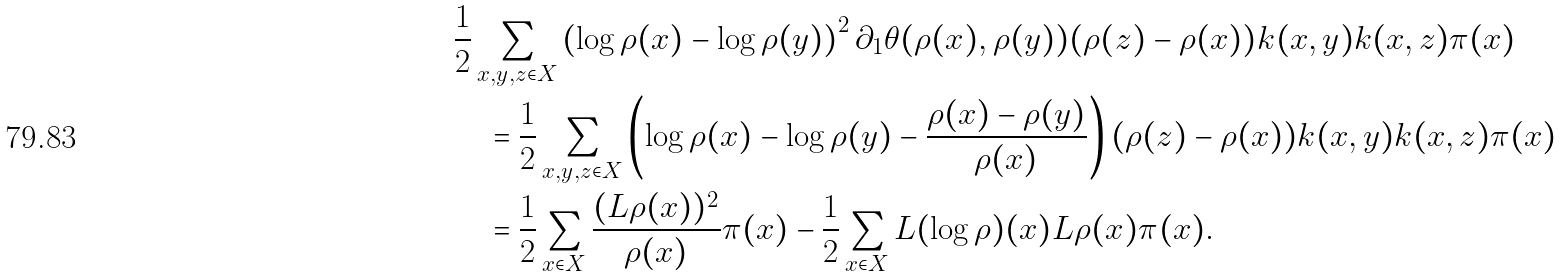<formula> <loc_0><loc_0><loc_500><loc_500>& \frac { 1 } { 2 } \sum _ { x , y , z \in X } \left ( \log \rho ( x ) - \log \rho ( y ) \right ) ^ { 2 } \partial _ { 1 } \theta ( \rho ( x ) , \rho ( y ) ) ( \rho ( z ) - \rho ( x ) ) k ( x , y ) k ( x , z ) \pi ( x ) \\ & \quad = \frac { 1 } { 2 } \sum _ { x , y , z \in X } \left ( \log \rho ( x ) - \log \rho ( y ) - \frac { \rho ( x ) - \rho ( y ) } { \rho ( x ) } \right ) ( \rho ( z ) - \rho ( x ) ) k ( x , y ) k ( x , z ) \pi ( x ) \\ & \quad = \frac { 1 } { 2 } \sum _ { x \in X } \frac { ( L \rho ( x ) ) ^ { 2 } } { \rho ( x ) } \pi ( x ) - \frac { 1 } { 2 } \sum _ { x \in X } L ( \log \rho ) ( x ) L \rho ( x ) \pi ( x ) .</formula> 